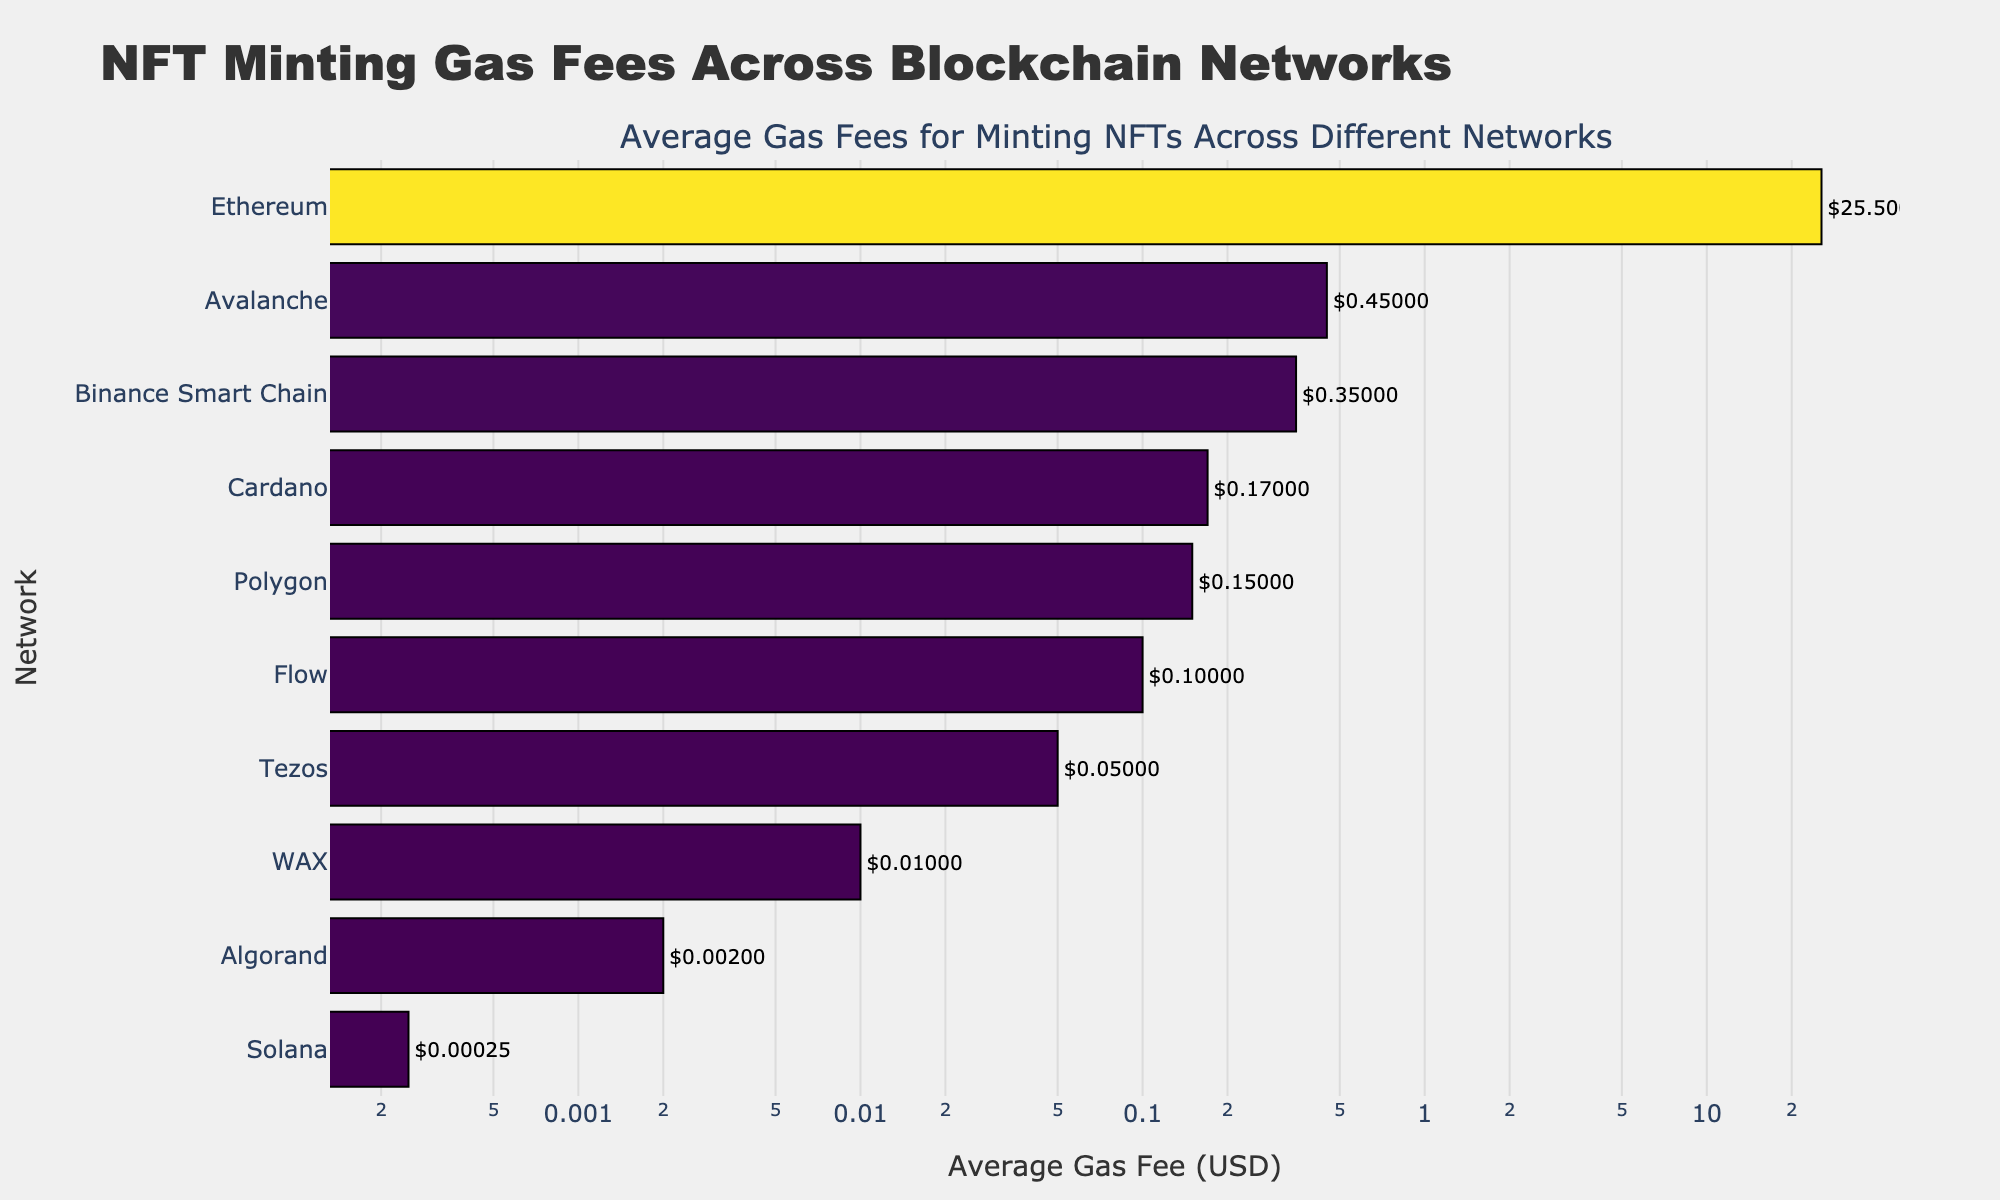What is the title of the plot? The title of the plot is displayed at the top center of the figure. It reads "NFT Minting Gas Fees Across Blockchain Networks".
Answer: NFT Minting Gas Fees Across Blockchain Networks Which network has the highest average gas fee? The bar with the longest length represents the highest average gas fee. Ethereum is shown with the highest average gas fee.
Answer: Ethereum What is the average gas fee for minting NFTs on Solana? The length of the bar corresponding to Solana displays the average gas fee next to it. It is $0.00025.
Answer: $0.00025 How many blockchain networks are represented in the plot? Counting each bar on the y-axis labels, there are 10 blockchain networks represented.
Answer: 10 Which network has a lower average gas fee, Binance Smart Chain or Avalanche? Compare the lengths of the bars for both networks. Binance Smart Chain has an average gas fee of $0.35 while Avalanche has $0.45. Binance Smart Chain's fee is lower.
Answer: Binance Smart Chain By how much is Polygon's average gas fee cheaper than Ethereum's? Subtract Polygon's average gas fee ($0.15) from Ethereum's average gas fee ($25.50).
Answer: $25.35 List the networks with average gas fees less than $0.10. Identify the bars with values less than $0.10: Solana, Tezos, WAX, and Algorand.
Answer: Solana, Tezos, WAX, Algorand Which network has a slightly higher average gas fee, Cardano or Avalanche? Compare the bar lengths of Cardano and Avalanche. Cardano has an average gas fee of $0.17 while Avalanche has $0.45. Avalanche's fee is higher.
Answer: Avalanche What is the combined average gas fee of Flow and WAX? Add the average gas fees of Flow ($0.10) and WAX ($0.01). The combined fee is $0.11.
Answer: $0.11 How many networks have average gas fees under $1? Count the number of bars with values less than $1. There are 9 such networks.
Answer: 9 